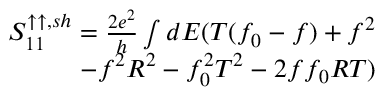Convert formula to latex. <formula><loc_0><loc_0><loc_500><loc_500>\begin{array} { r } { S _ { 1 1 } ^ { \uparrow \uparrow , s h } = \frac { 2 e ^ { 2 } } { h } \int d E ( T ( f _ { 0 } - f ) + f ^ { 2 } } \\ { - f ^ { 2 } R ^ { 2 } - f _ { 0 } ^ { 2 } T ^ { 2 } - 2 f f _ { 0 } R T ) } \end{array}</formula> 